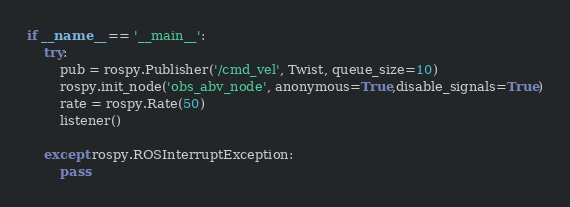<code> <loc_0><loc_0><loc_500><loc_500><_Python_>
if __name__ == '__main__':
    try:
        pub = rospy.Publisher('/cmd_vel', Twist, queue_size=10)
        rospy.init_node('obs_abv_node', anonymous=True,disable_signals=True)
        rate = rospy.Rate(50)
        listener()

    except rospy.ROSInterruptException:
        pass

</code> 